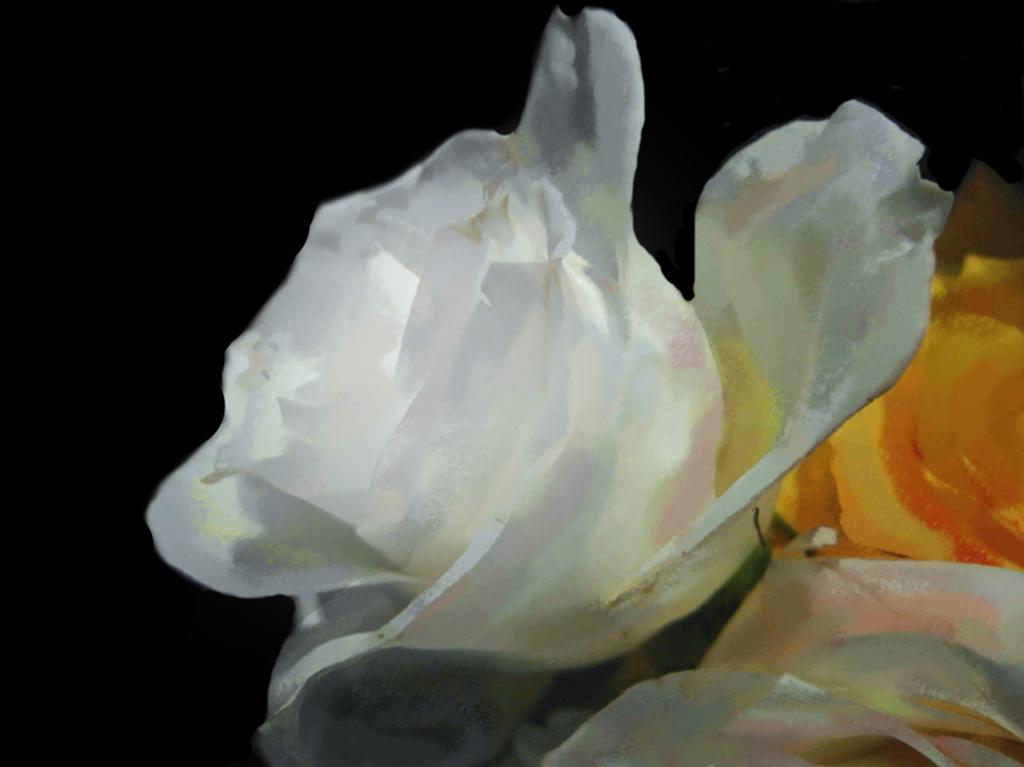What type of objects are present in the image? There are flowers in the image. Can you describe the colors of the flowers? The flowers are in white, yellow, and orange colors. What is the color of the background in the image? There is a black background in the image. How many trains can be seen in the image? There are no trains present in the image; it features flowers with a black background. What type of spark is visible in the image? There is no spark present in the image. 